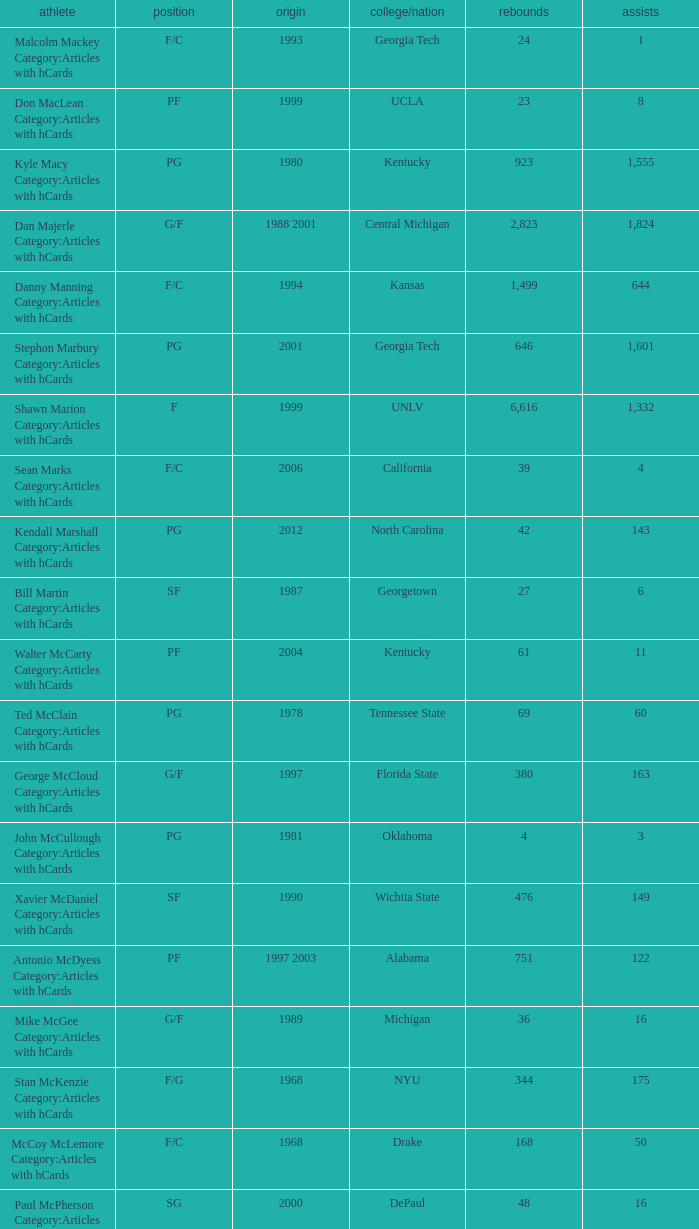Who has the high assists in 2000? 16.0. 